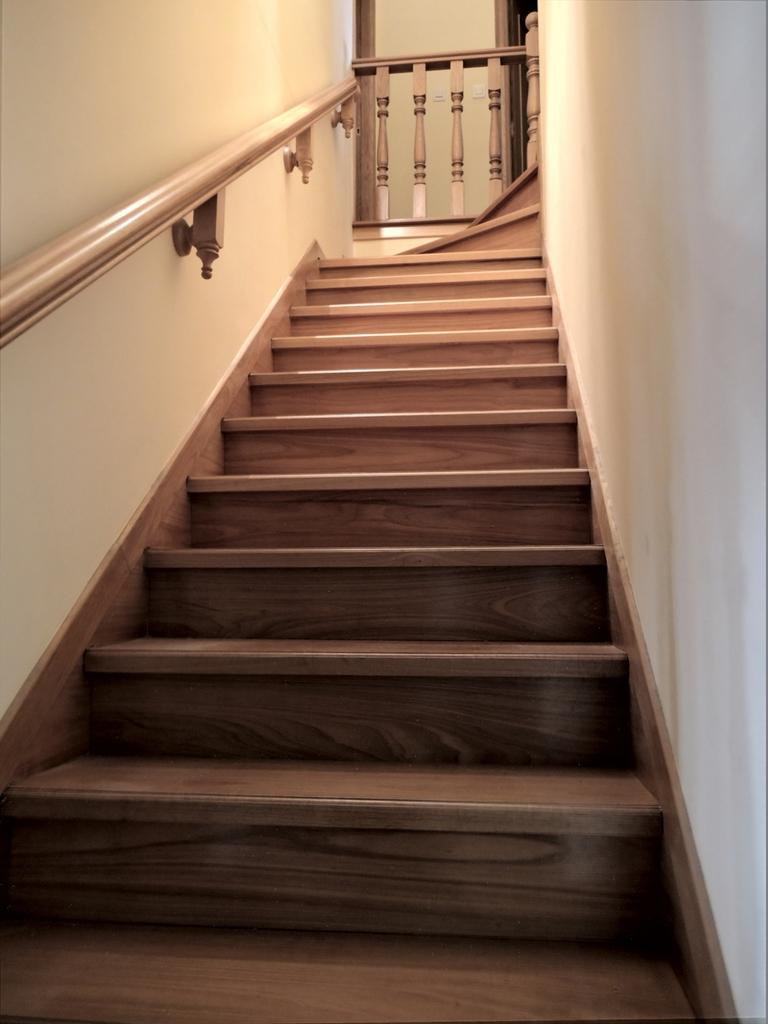What type of structure is present in the image? There is a staircase in the image. What else can be seen in the image besides the staircase? There is a wall in the image. Where was the image taken? The image was taken in a room. How many frogs are sitting on the staircase in the image? There are no frogs present in the image. What type of clover can be seen growing on the wall in the image? There is no clover present in the image; it only features a staircase and a wall. 